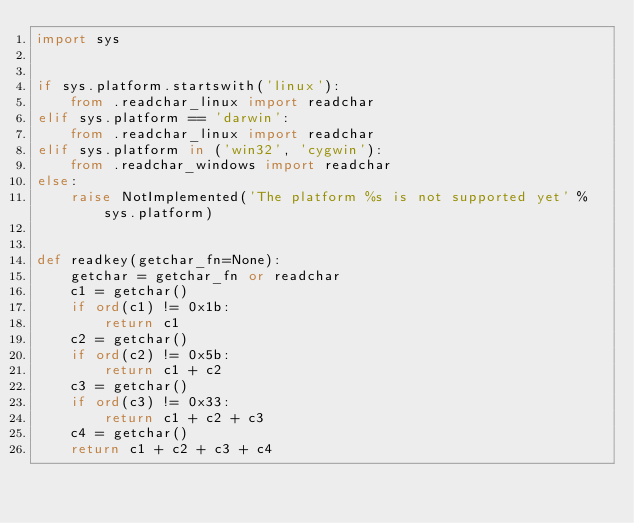Convert code to text. <code><loc_0><loc_0><loc_500><loc_500><_Python_>import sys


if sys.platform.startswith('linux'):
    from .readchar_linux import readchar
elif sys.platform == 'darwin':
    from .readchar_linux import readchar
elif sys.platform in ('win32', 'cygwin'):
    from .readchar_windows import readchar
else:
    raise NotImplemented('The platform %s is not supported yet' % sys.platform)


def readkey(getchar_fn=None):
    getchar = getchar_fn or readchar
    c1 = getchar()
    if ord(c1) != 0x1b:
        return c1
    c2 = getchar()
    if ord(c2) != 0x5b:
        return c1 + c2
    c3 = getchar()
    if ord(c3) != 0x33:
        return c1 + c2 + c3
    c4 = getchar()
    return c1 + c2 + c3 + c4
</code> 